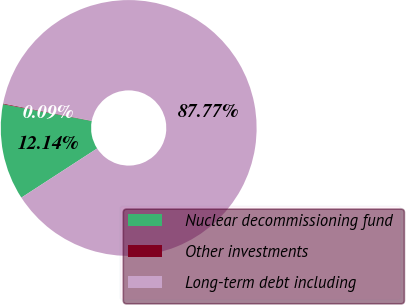<chart> <loc_0><loc_0><loc_500><loc_500><pie_chart><fcel>Nuclear decommissioning fund<fcel>Other investments<fcel>Long-term debt including<nl><fcel>12.14%<fcel>0.09%<fcel>87.76%<nl></chart> 